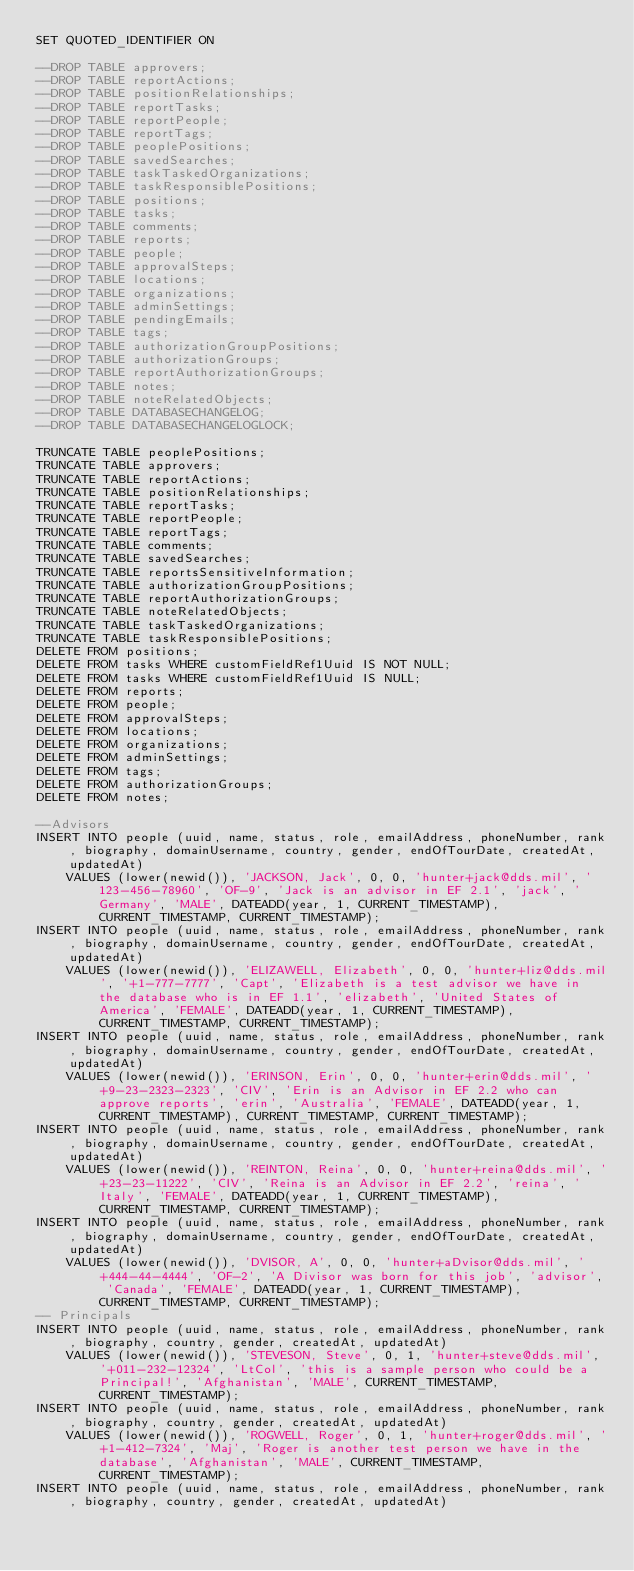Convert code to text. <code><loc_0><loc_0><loc_500><loc_500><_SQL_>SET QUOTED_IDENTIFIER ON

--DROP TABLE approvers;
--DROP TABLE reportActions;
--DROP TABLE positionRelationships;
--DROP TABLE reportTasks;
--DROP TABLE reportPeople;
--DROP TABLE reportTags;
--DROP TABLE peoplePositions;
--DROP TABLE savedSearches;
--DROP TABLE taskTaskedOrganizations;
--DROP TABLE taskResponsiblePositions;
--DROP TABLE positions;
--DROP TABLE tasks;
--DROP TABLE comments;
--DROP TABLE reports;
--DROP TABLE people;
--DROP TABLE approvalSteps;
--DROP TABLE locations;
--DROP TABLE organizations;
--DROP TABLE adminSettings;
--DROP TABLE pendingEmails;
--DROP TABLE tags;
--DROP TABLE authorizationGroupPositions;
--DROP TABLE authorizationGroups;
--DROP TABLE reportAuthorizationGroups;
--DROP TABLE notes;
--DROP TABLE noteRelatedObjects;
--DROP TABLE DATABASECHANGELOG;
--DROP TABLE DATABASECHANGELOGLOCK;

TRUNCATE TABLE peoplePositions;
TRUNCATE TABLE approvers;
TRUNCATE TABLE reportActions;
TRUNCATE TABLE positionRelationships;
TRUNCATE TABLE reportTasks;
TRUNCATE TABLE reportPeople;
TRUNCATE TABLE reportTags;
TRUNCATE TABLE comments;
TRUNCATE TABLE savedSearches;
TRUNCATE TABLE reportsSensitiveInformation;
TRUNCATE TABLE authorizationGroupPositions;
TRUNCATE TABLE reportAuthorizationGroups;
TRUNCATE TABLE noteRelatedObjects;
TRUNCATE TABLE taskTaskedOrganizations;
TRUNCATE TABLE taskResponsiblePositions;
DELETE FROM positions;
DELETE FROM tasks WHERE customFieldRef1Uuid IS NOT NULL;
DELETE FROM tasks WHERE customFieldRef1Uuid IS NULL;
DELETE FROM reports;
DELETE FROM people;
DELETE FROM approvalSteps;
DELETE FROM locations;
DELETE FROM organizations;
DELETE FROM adminSettings;
DELETE FROM tags;
DELETE FROM authorizationGroups;
DELETE FROM notes;

--Advisors
INSERT INTO people (uuid, name, status, role, emailAddress, phoneNumber, rank, biography, domainUsername, country, gender, endOfTourDate, createdAt, updatedAt)
	VALUES (lower(newid()), 'JACKSON, Jack', 0, 0, 'hunter+jack@dds.mil', '123-456-78960', 'OF-9', 'Jack is an advisor in EF 2.1', 'jack', 'Germany', 'MALE', DATEADD(year, 1, CURRENT_TIMESTAMP), CURRENT_TIMESTAMP, CURRENT_TIMESTAMP);
INSERT INTO people (uuid, name, status, role, emailAddress, phoneNumber, rank, biography, domainUsername, country, gender, endOfTourDate, createdAt, updatedAt)
	VALUES (lower(newid()), 'ELIZAWELL, Elizabeth', 0, 0, 'hunter+liz@dds.mil', '+1-777-7777', 'Capt', 'Elizabeth is a test advisor we have in the database who is in EF 1.1', 'elizabeth', 'United States of America', 'FEMALE', DATEADD(year, 1, CURRENT_TIMESTAMP), CURRENT_TIMESTAMP, CURRENT_TIMESTAMP);
INSERT INTO people (uuid, name, status, role, emailAddress, phoneNumber, rank, biography, domainUsername, country, gender, endOfTourDate, createdAt, updatedAt)
	VALUES (lower(newid()), 'ERINSON, Erin', 0, 0, 'hunter+erin@dds.mil', '+9-23-2323-2323', 'CIV', 'Erin is an Advisor in EF 2.2 who can approve reports', 'erin', 'Australia', 'FEMALE', DATEADD(year, 1, CURRENT_TIMESTAMP), CURRENT_TIMESTAMP, CURRENT_TIMESTAMP);
INSERT INTO people (uuid, name, status, role, emailAddress, phoneNumber, rank, biography, domainUsername, country, gender, endOfTourDate, createdAt, updatedAt)
	VALUES (lower(newid()), 'REINTON, Reina', 0, 0, 'hunter+reina@dds.mil', '+23-23-11222', 'CIV', 'Reina is an Advisor in EF 2.2', 'reina', 'Italy', 'FEMALE', DATEADD(year, 1, CURRENT_TIMESTAMP), CURRENT_TIMESTAMP, CURRENT_TIMESTAMP);
INSERT INTO people (uuid, name, status, role, emailAddress, phoneNumber, rank, biography, domainUsername, country, gender, endOfTourDate, createdAt, updatedAt)
	VALUES (lower(newid()), 'DVISOR, A', 0, 0, 'hunter+aDvisor@dds.mil', '+444-44-4444', 'OF-2', 'A Divisor was born for this job', 'advisor', 'Canada', 'FEMALE', DATEADD(year, 1, CURRENT_TIMESTAMP), CURRENT_TIMESTAMP, CURRENT_TIMESTAMP);
-- Principals
INSERT INTO people (uuid, name, status, role, emailAddress, phoneNumber, rank, biography, country, gender, createdAt, updatedAt)
	VALUES (lower(newid()), 'STEVESON, Steve', 0, 1, 'hunter+steve@dds.mil', '+011-232-12324', 'LtCol', 'this is a sample person who could be a Principal!', 'Afghanistan', 'MALE', CURRENT_TIMESTAMP, CURRENT_TIMESTAMP);
INSERT INTO people (uuid, name, status, role, emailAddress, phoneNumber, rank, biography, country, gender, createdAt, updatedAt)
	VALUES (lower(newid()), 'ROGWELL, Roger', 0, 1, 'hunter+roger@dds.mil', '+1-412-7324', 'Maj', 'Roger is another test person we have in the database', 'Afghanistan', 'MALE', CURRENT_TIMESTAMP, CURRENT_TIMESTAMP);
INSERT INTO people (uuid, name, status, role, emailAddress, phoneNumber, rank, biography, country, gender, createdAt, updatedAt)</code> 